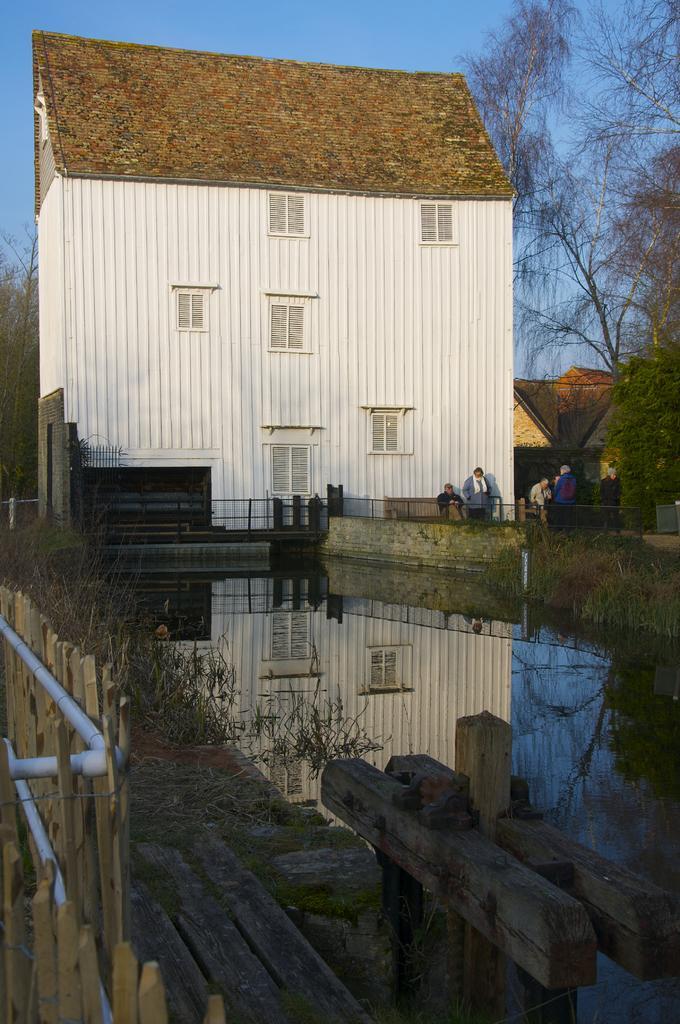Could you give a brief overview of what you see in this image? In this image there are buildings and we can see people. On the left there is a fence. In the center there is water and we can see railings. In the background there are trees and sky. 